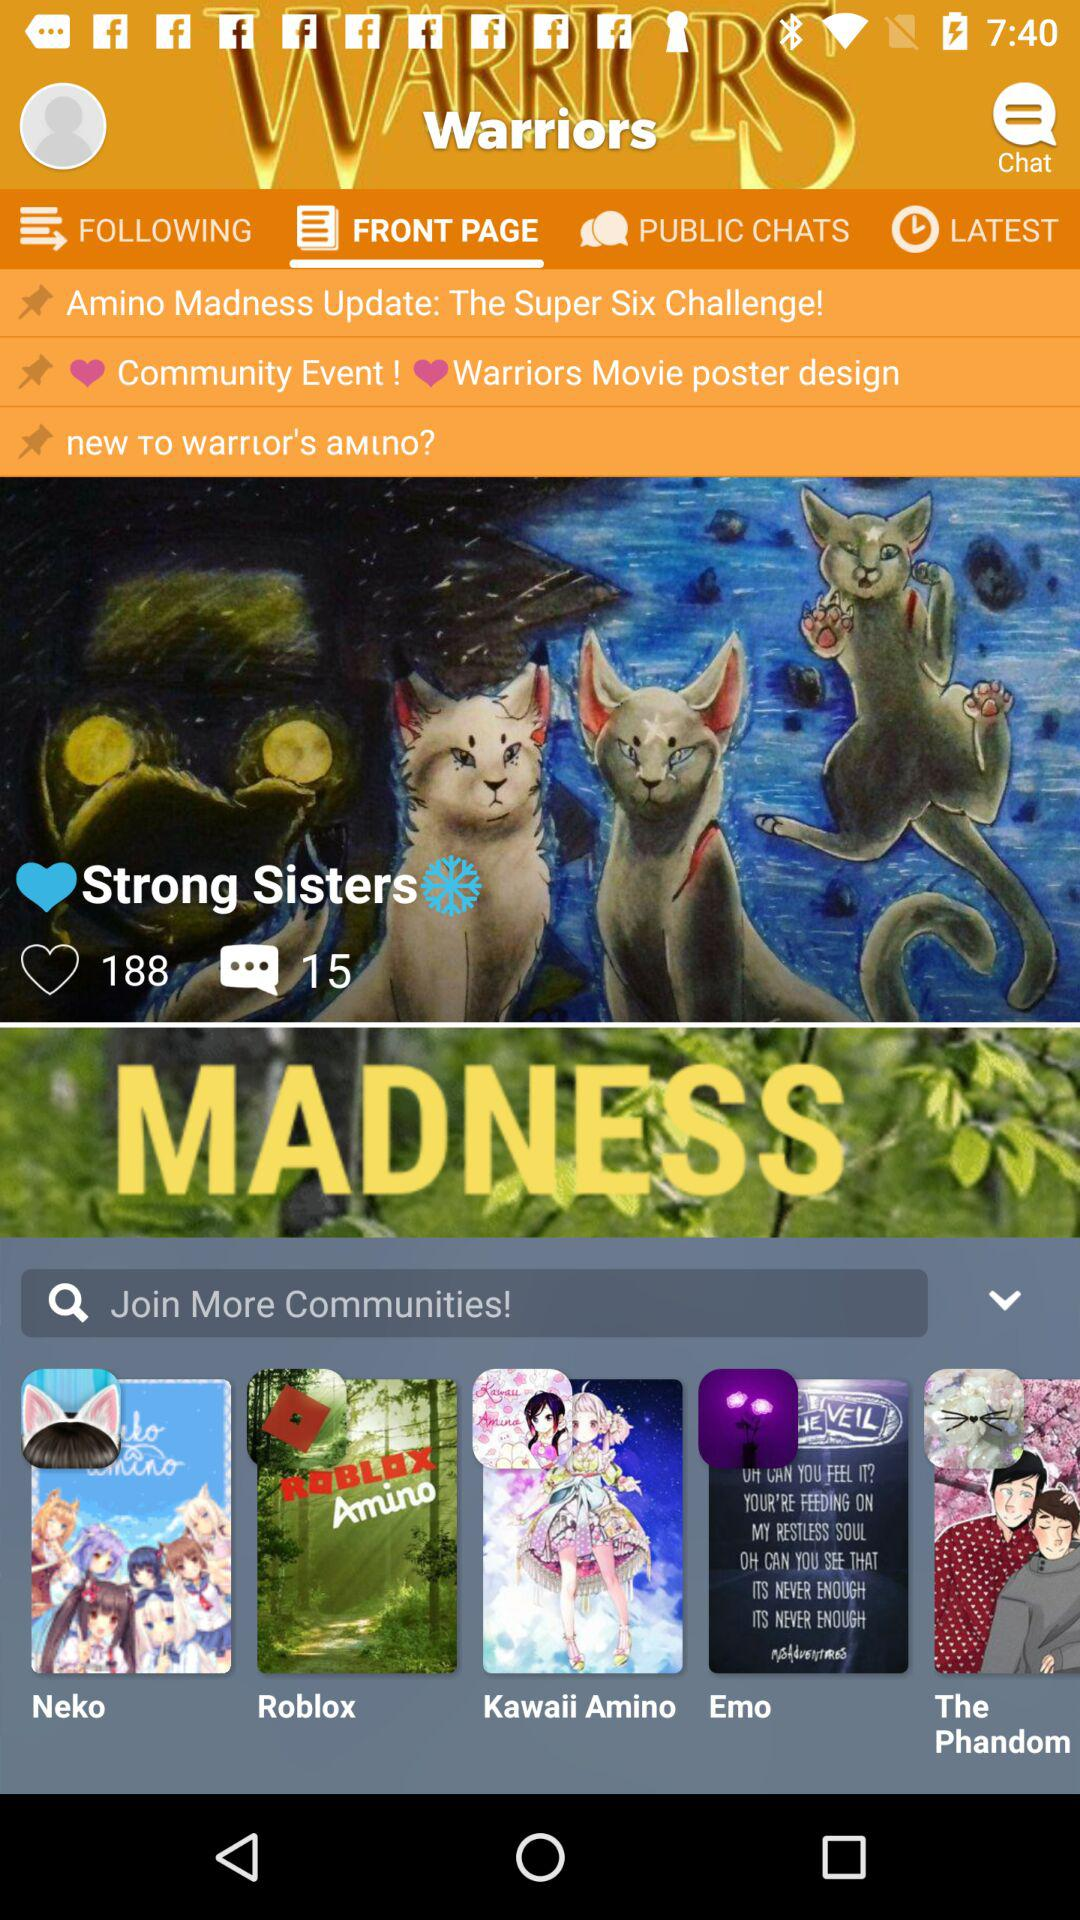Which tab has been selected? The selected tab is "FRONT PAGE". 